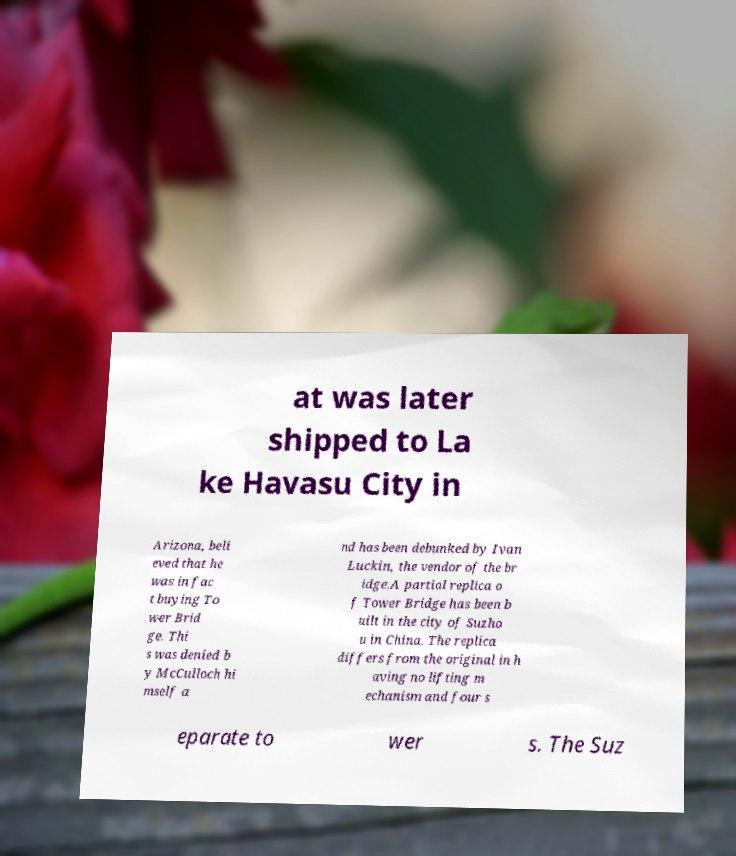Could you assist in decoding the text presented in this image and type it out clearly? at was later shipped to La ke Havasu City in Arizona, beli eved that he was in fac t buying To wer Brid ge. Thi s was denied b y McCulloch hi mself a nd has been debunked by Ivan Luckin, the vendor of the br idge.A partial replica o f Tower Bridge has been b uilt in the city of Suzho u in China. The replica differs from the original in h aving no lifting m echanism and four s eparate to wer s. The Suz 